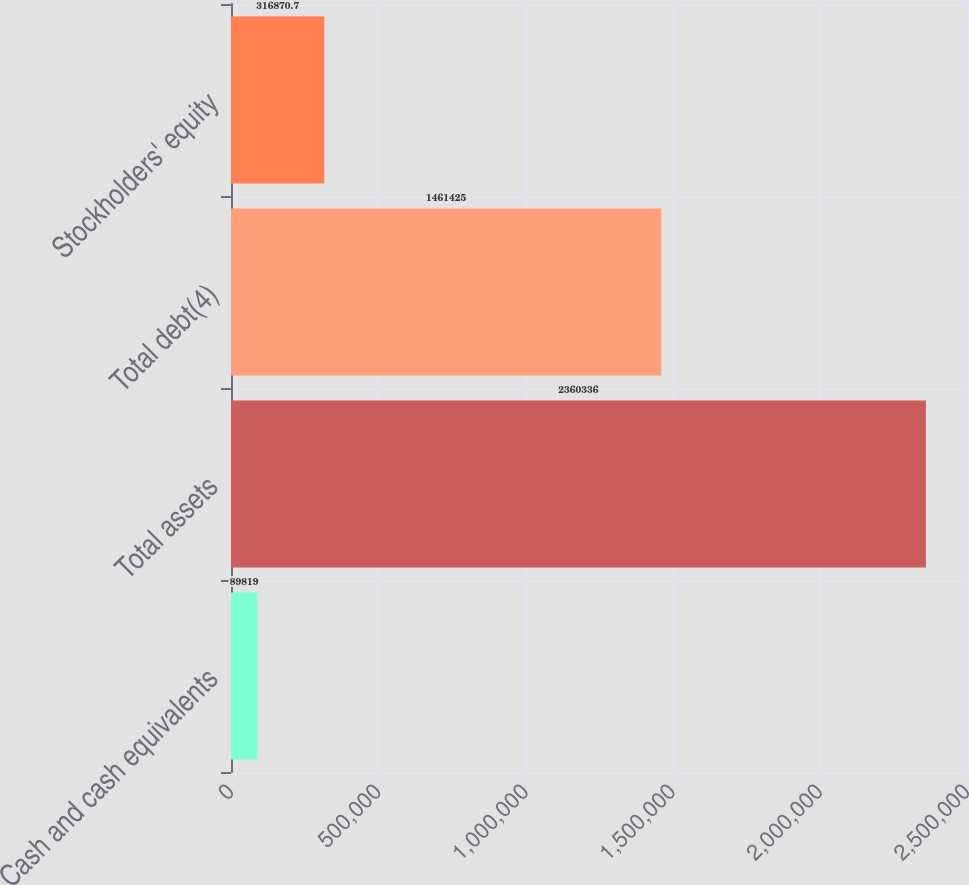<chart> <loc_0><loc_0><loc_500><loc_500><bar_chart><fcel>Cash and cash equivalents<fcel>Total assets<fcel>Total debt(4)<fcel>Stockholders' equity<nl><fcel>89819<fcel>2.36034e+06<fcel>1.46142e+06<fcel>316871<nl></chart> 